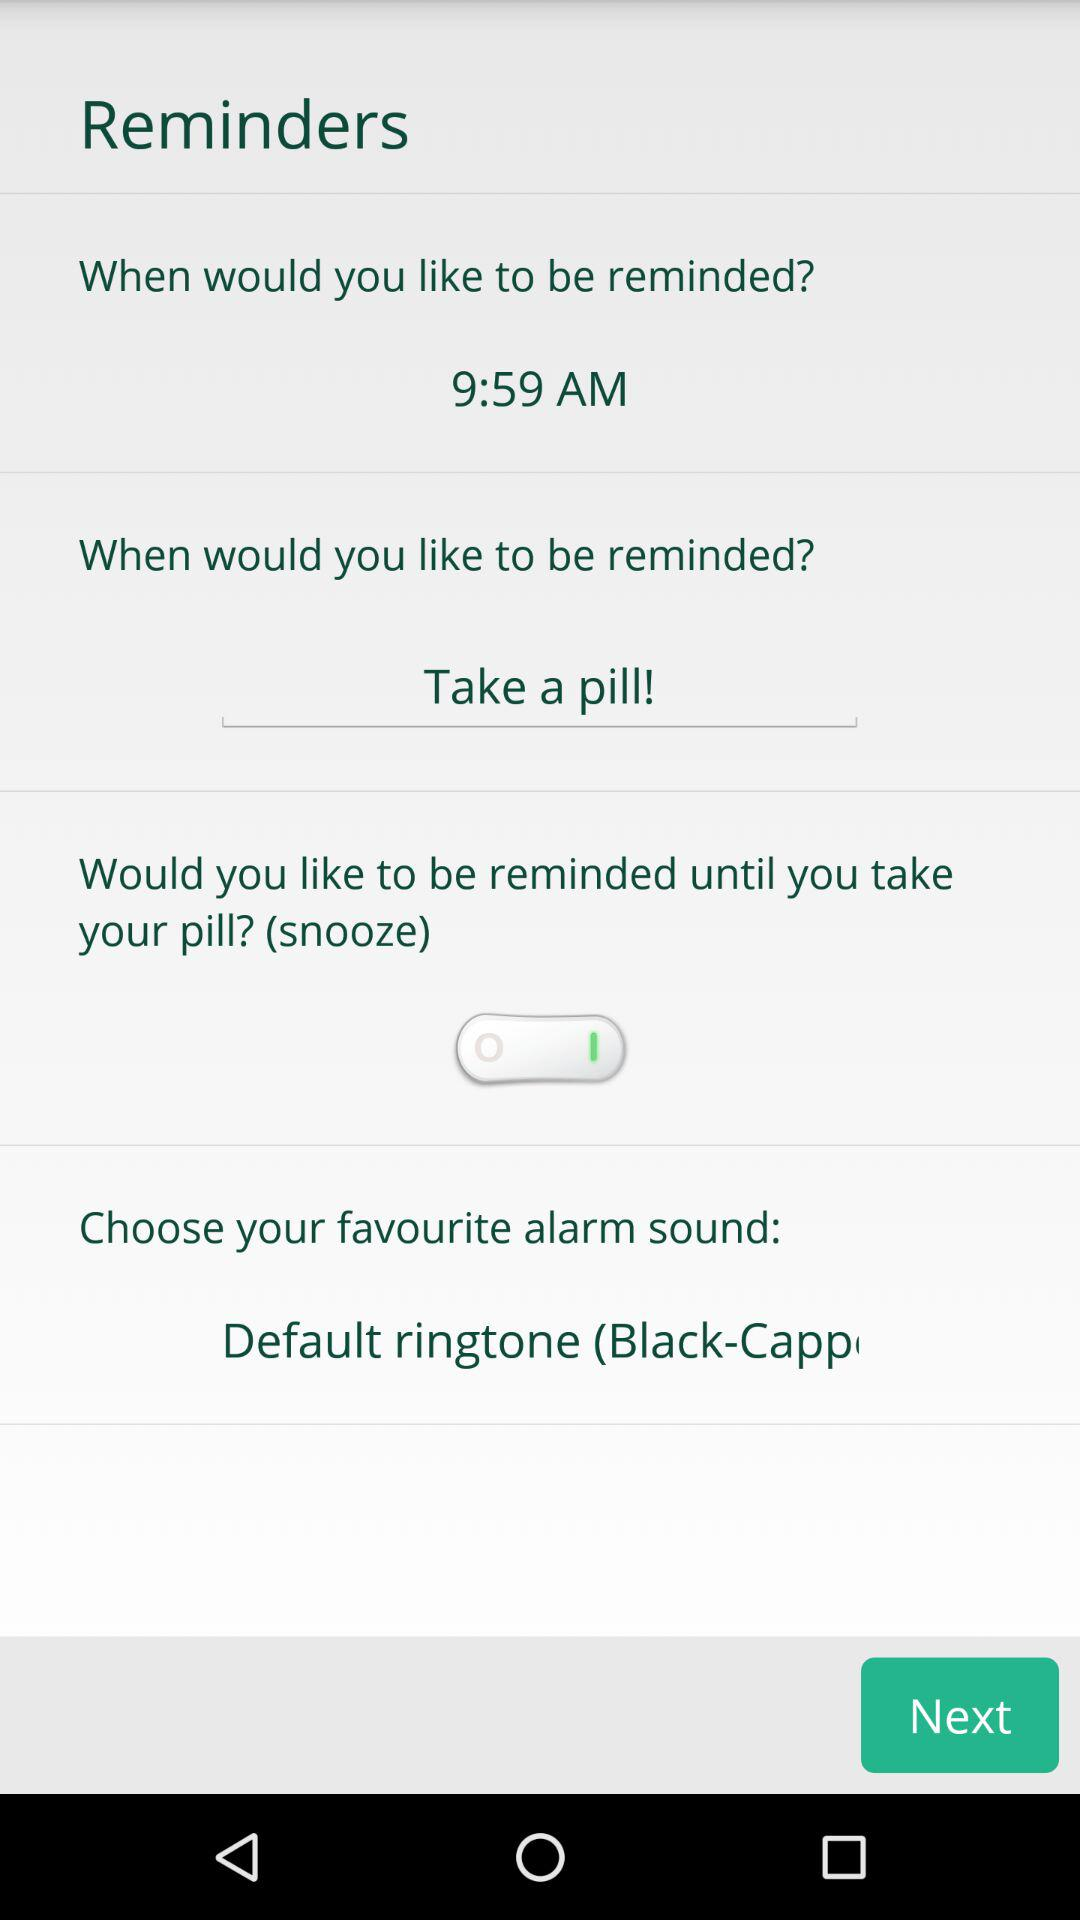Which ringtone is chose?
When the provided information is insufficient, respond with <no answer>. <no answer> 